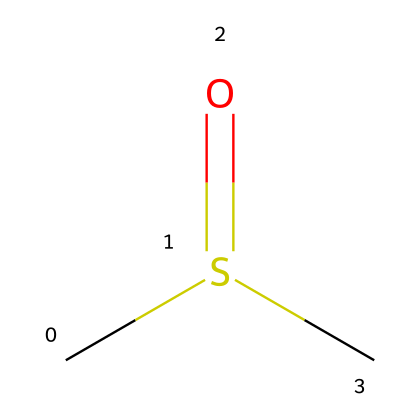What is the molecular formula of dimethyl sulfoxide? The SMILES representation includes two carbon atoms (C), one sulfur atom (S), and one oxygen atom (O). Therefore, the molecular formula can be constructed as C2H6OS considering the hydrogens associated with carbon and sulfur.
Answer: C2H6OS How many carbon atoms are present in this structure? By analyzing the SMILES notation, there are two "C" characters, indicating the presence of two carbon atoms in the molecule.
Answer: 2 What type of functional group is present in dimethyl sulfoxide? The presence of the "S(=O)" notation indicates that there is a sulfoxide functional group, characterized by a sulfur atom double bonded to an oxygen atom and connected to carbon atoms.
Answer: sulfoxide Does dimethyl sulfoxide contain any double bonds? Yes, the "S(=O)" notation indicates that there is a double bond between the sulfur atom and the oxygen atom, which contributes to the presence of a functional group in the molecule.
Answer: Yes Which element has a formal positive charge in this structure? Upon analyzing the SMILES representation, no elements in this structure display a positive formal charge, as the sulfur atom is in its stable state with a double bond to oxygen and single bonds to carbon atoms.
Answer: None What is the total number of hydrogen atoms in dimethyl sulfoxide? Each carbon in DMSO can accommodate three hydrogen atoms, and as there are two carbon atoms, we would initially expect six hydrogen atoms. However, one of the hydrogen atoms is replaced by the sulfur, resulting in a total of six hydrogen atoms still connected to the two carbons.
Answer: 6 